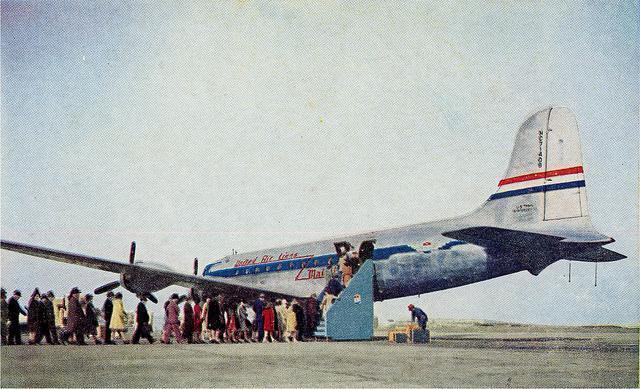How many dogs are following the horse?
Give a very brief answer. 0. 